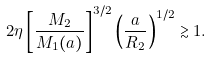Convert formula to latex. <formula><loc_0><loc_0><loc_500><loc_500>2 \eta \left [ \frac { M _ { 2 } } { M _ { 1 } ( a ) } \right ] ^ { 3 / 2 } \left ( \frac { a } { R _ { 2 } } \right ) ^ { 1 / 2 } \gtrsim 1 .</formula> 